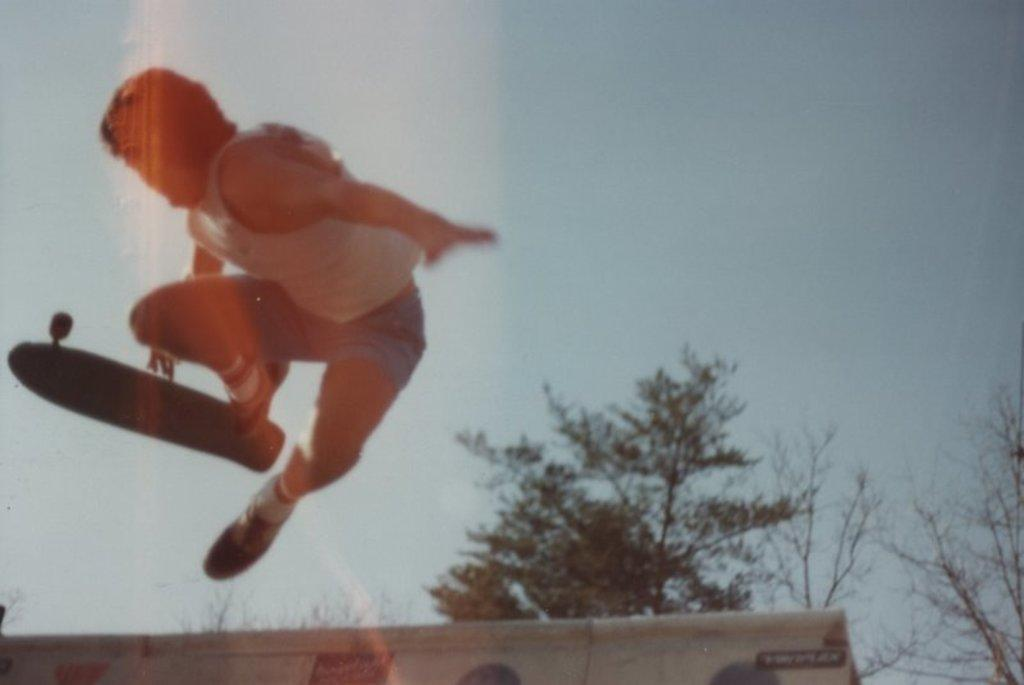What is the main subject of the image? There is a person riding a skateboard in the image. What is the person doing while riding the skateboard? The person is in the air. What type of natural environment is visible in the image? There are trees in the image. What can be seen in the background of the image? The sky is visible in the background of the image. What property does the spy own in the image? There is no spy or property present in the image. What mark can be seen on the skateboard in the person is riding in the image? There is no mark visible on the skateboard in the image. 